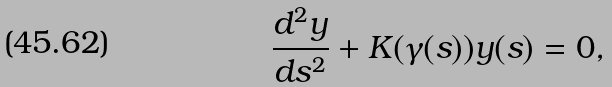Convert formula to latex. <formula><loc_0><loc_0><loc_500><loc_500>\frac { d ^ { 2 } y } { d s ^ { 2 } } + K ( \gamma ( s ) ) y ( s ) = 0 ,</formula> 